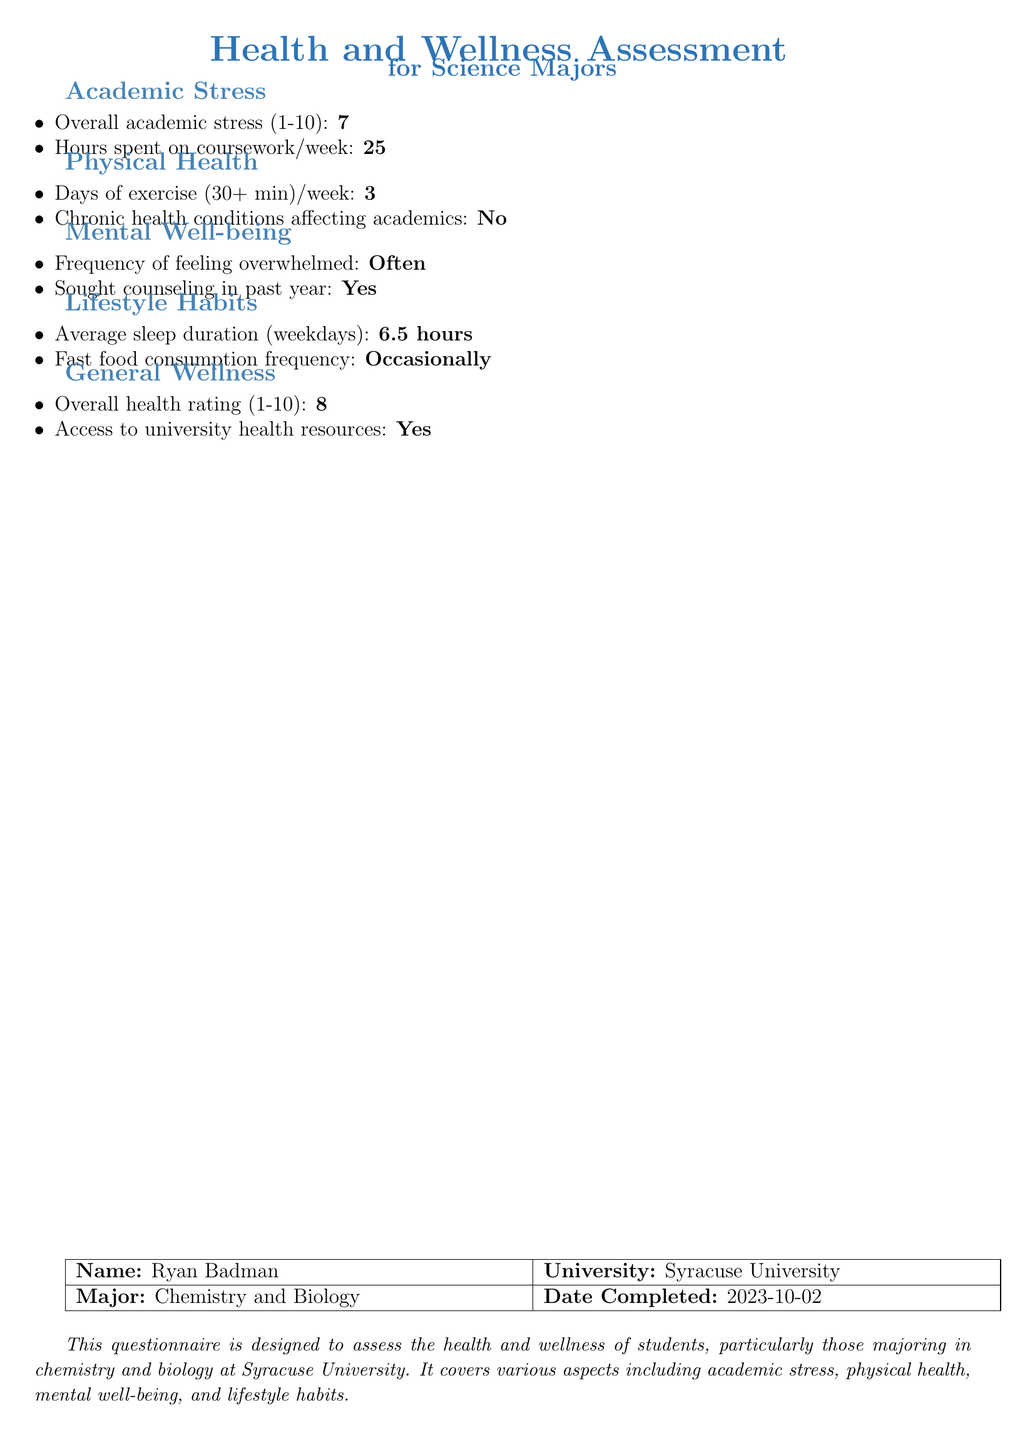What is Ryan Badman's overall academic stress rating? The overall academic stress rating is mentioned explicitly in the document as a number from 1 to 10.
Answer: 7 How many hours does Ryan spend on coursework each week? The document specifies the number of hours spent on coursework in a weekly format.
Answer: 25 What is the frequency of Ryan feeling overwhelmed? The document indicates the frequency of feeling overwhelmed in a simple word format.
Answer: Often How many days a week does Ryan exercise for 30 minutes or more? The number of days that Ryan exercises is directly noted in the physical health section.
Answer: 3 What is the average sleep duration for Ryan on weekdays? The average sleep duration is clearly stated in hours.
Answer: 6.5 hours What is Ryan's overall health rating out of 10? The overall health rating is explicitly provided in the document as a number from 1 to 10.
Answer: 8 Did Ryan seek counseling in the past year? The document answers whether Ryan sought counseling as a yes or no response.
Answer: Yes What major is Ryan Badman studying at Syracuse University? The document lists Ryan's major under his personal information.
Answer: Chemistry and Biology What is the frequency of Ryan's fast food consumption? The document explicitly indicates the frequency of fast food consumption in a straightforward term.
Answer: Occasionally 